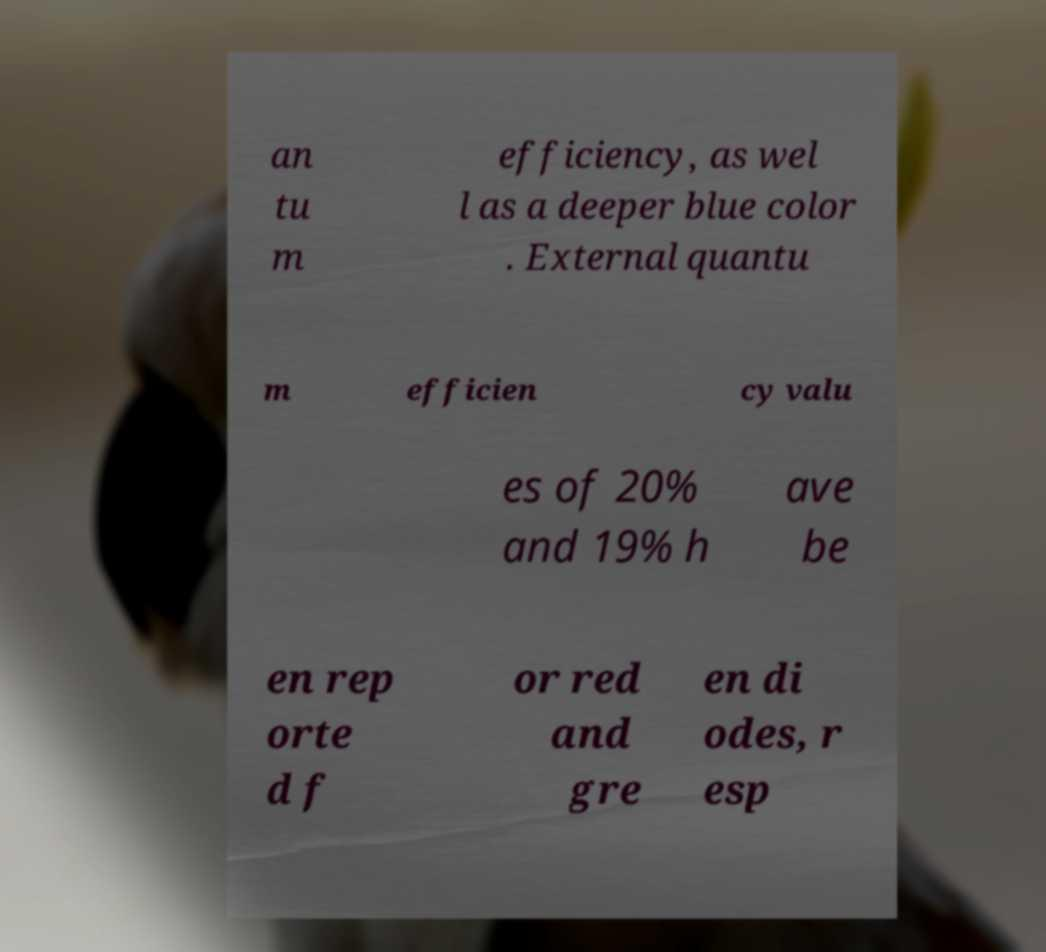What messages or text are displayed in this image? I need them in a readable, typed format. an tu m efficiency, as wel l as a deeper blue color . External quantu m efficien cy valu es of 20% and 19% h ave be en rep orte d f or red and gre en di odes, r esp 